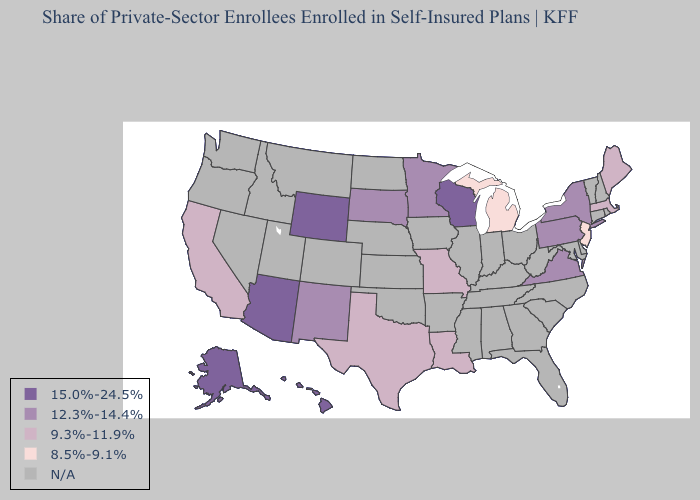Among the states that border New Mexico , does Texas have the highest value?
Quick response, please. No. Name the states that have a value in the range N/A?
Concise answer only. Alabama, Arkansas, Colorado, Connecticut, Delaware, Florida, Georgia, Idaho, Illinois, Indiana, Iowa, Kansas, Kentucky, Maryland, Mississippi, Montana, Nebraska, Nevada, New Hampshire, North Carolina, North Dakota, Ohio, Oklahoma, Oregon, Rhode Island, South Carolina, Tennessee, Utah, Vermont, Washington, West Virginia. Name the states that have a value in the range N/A?
Short answer required. Alabama, Arkansas, Colorado, Connecticut, Delaware, Florida, Georgia, Idaho, Illinois, Indiana, Iowa, Kansas, Kentucky, Maryland, Mississippi, Montana, Nebraska, Nevada, New Hampshire, North Carolina, North Dakota, Ohio, Oklahoma, Oregon, Rhode Island, South Carolina, Tennessee, Utah, Vermont, Washington, West Virginia. Name the states that have a value in the range N/A?
Give a very brief answer. Alabama, Arkansas, Colorado, Connecticut, Delaware, Florida, Georgia, Idaho, Illinois, Indiana, Iowa, Kansas, Kentucky, Maryland, Mississippi, Montana, Nebraska, Nevada, New Hampshire, North Carolina, North Dakota, Ohio, Oklahoma, Oregon, Rhode Island, South Carolina, Tennessee, Utah, Vermont, Washington, West Virginia. Name the states that have a value in the range 12.3%-14.4%?
Concise answer only. Minnesota, New Mexico, New York, Pennsylvania, South Dakota, Virginia. What is the value of Minnesota?
Keep it brief. 12.3%-14.4%. Among the states that border Delaware , does New Jersey have the lowest value?
Keep it brief. Yes. What is the value of Massachusetts?
Write a very short answer. 9.3%-11.9%. Name the states that have a value in the range N/A?
Give a very brief answer. Alabama, Arkansas, Colorado, Connecticut, Delaware, Florida, Georgia, Idaho, Illinois, Indiana, Iowa, Kansas, Kentucky, Maryland, Mississippi, Montana, Nebraska, Nevada, New Hampshire, North Carolina, North Dakota, Ohio, Oklahoma, Oregon, Rhode Island, South Carolina, Tennessee, Utah, Vermont, Washington, West Virginia. Does Michigan have the lowest value in the USA?
Quick response, please. Yes. Does Alaska have the highest value in the USA?
Write a very short answer. Yes. How many symbols are there in the legend?
Be succinct. 5. What is the value of Arizona?
Quick response, please. 15.0%-24.5%. What is the value of Indiana?
Give a very brief answer. N/A. 